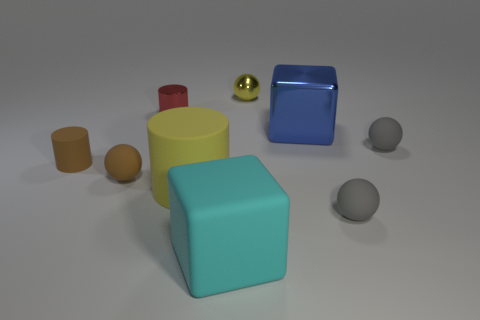Add 1 gray rubber objects. How many objects exist? 10 Subtract all matte spheres. How many spheres are left? 1 Subtract all brown cubes. How many gray balls are left? 2 Subtract all brown spheres. How many spheres are left? 3 Subtract all cubes. How many objects are left? 7 Add 6 small red shiny things. How many small red shiny things are left? 7 Add 4 yellow rubber objects. How many yellow rubber objects exist? 5 Subtract 1 brown cylinders. How many objects are left? 8 Subtract all brown spheres. Subtract all blue cylinders. How many spheres are left? 3 Subtract all blocks. Subtract all big purple rubber cubes. How many objects are left? 7 